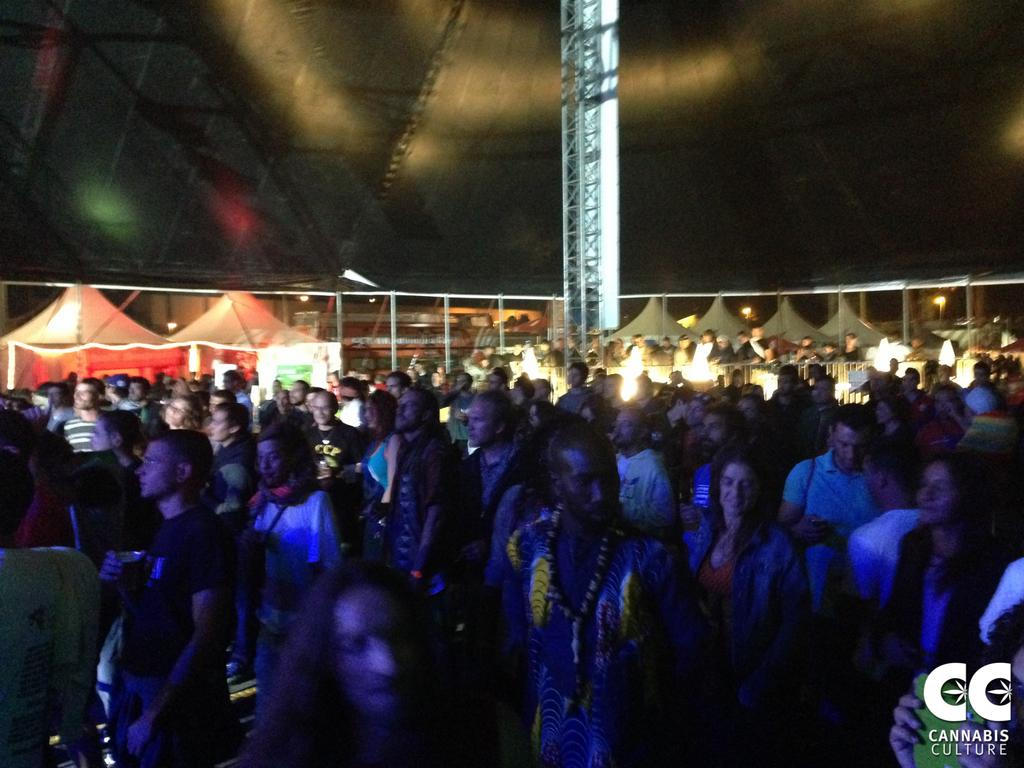Who or what can be seen in the image? There are people in the image. What can be seen in the background of the image? There are tents, lights, rods, a tower, and a fence in the background of the image. Can you describe the logo and text in the bottom right side of the image? There is a logo and text in the bottom right side of the image. What type of chess pieces can be seen in the image? There are no chess pieces present in the image. What kind of art is displayed on the tower in the background? The tower in the background does not have any art displayed on it; it is a structural element. 